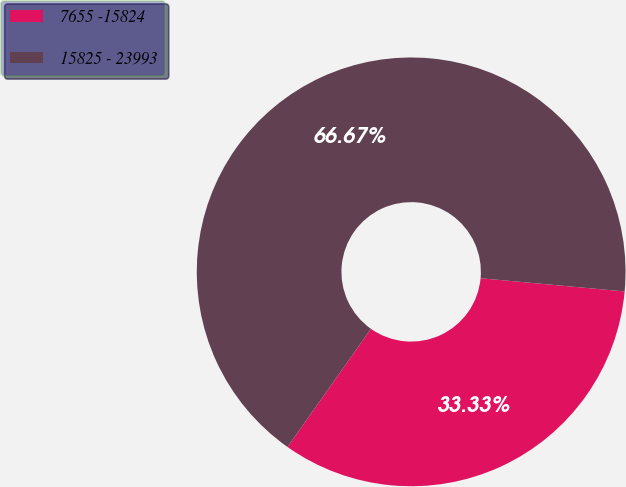Convert chart to OTSL. <chart><loc_0><loc_0><loc_500><loc_500><pie_chart><fcel>7655 -15824<fcel>15825 - 23993<nl><fcel>33.33%<fcel>66.67%<nl></chart> 